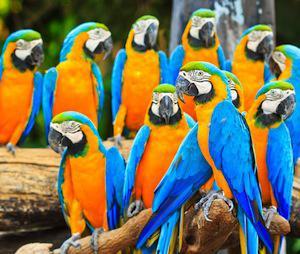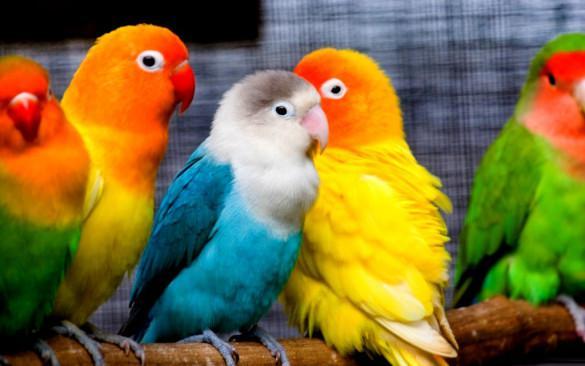The first image is the image on the left, the second image is the image on the right. Given the left and right images, does the statement "The right image shows a row of at least five blue and yellow-orange parrots." hold true? Answer yes or no. No. 